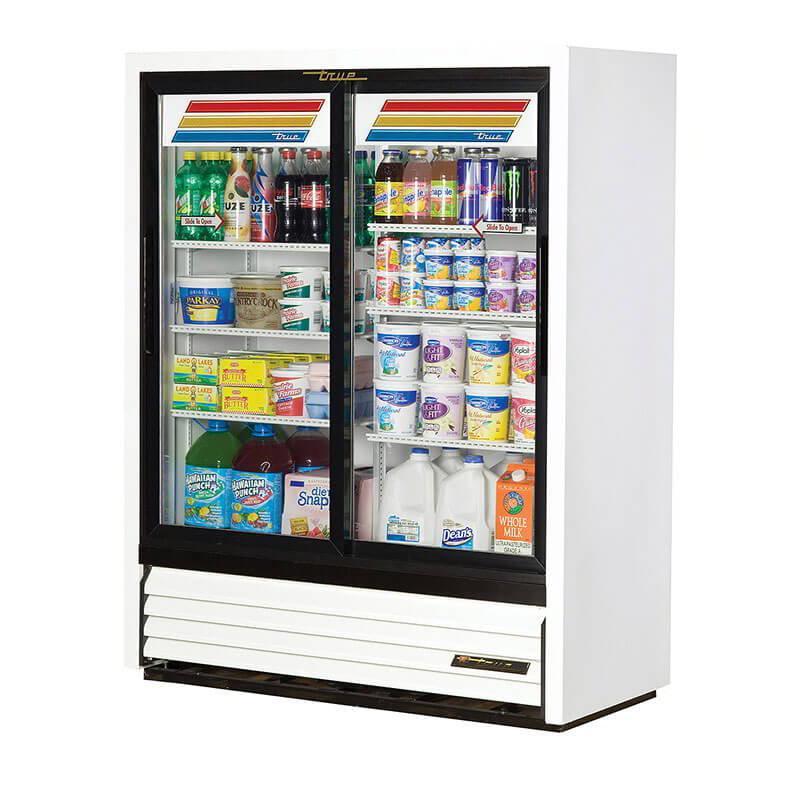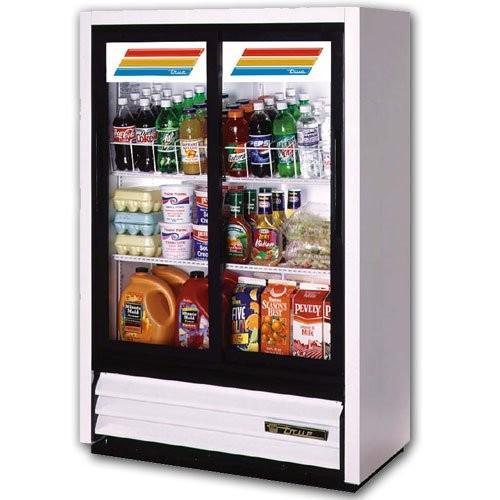The first image is the image on the left, the second image is the image on the right. Evaluate the accuracy of this statement regarding the images: "The cooler display in the right image has three colored lines across the top that run nearly the width of the machine.". Is it true? Answer yes or no. No. 